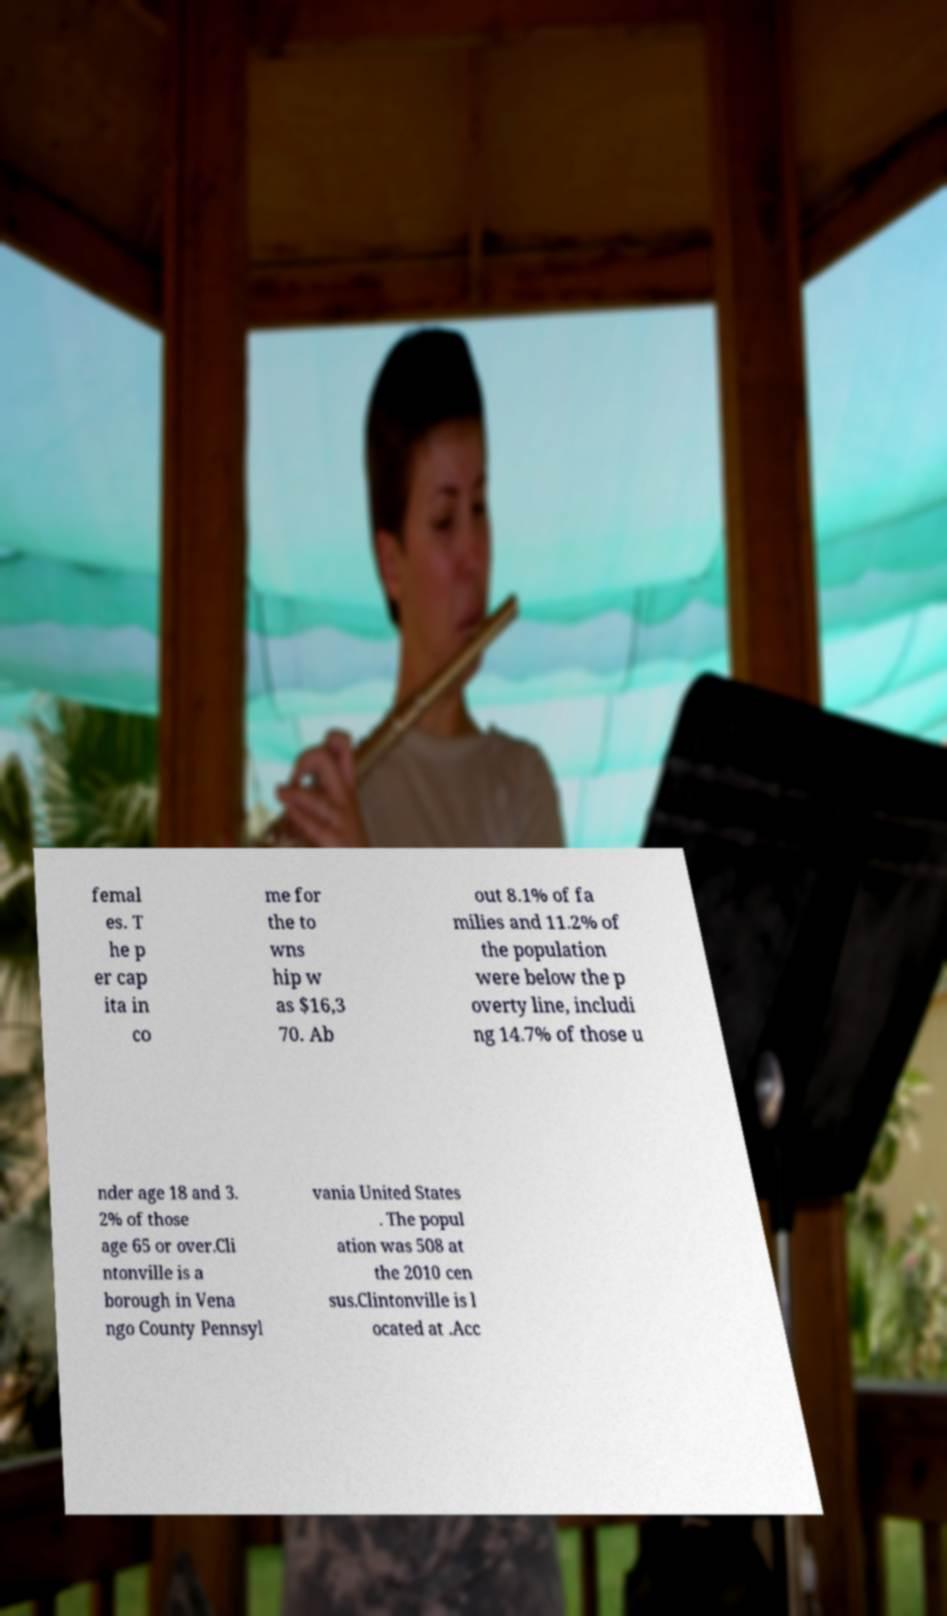There's text embedded in this image that I need extracted. Can you transcribe it verbatim? femal es. T he p er cap ita in co me for the to wns hip w as $16,3 70. Ab out 8.1% of fa milies and 11.2% of the population were below the p overty line, includi ng 14.7% of those u nder age 18 and 3. 2% of those age 65 or over.Cli ntonville is a borough in Vena ngo County Pennsyl vania United States . The popul ation was 508 at the 2010 cen sus.Clintonville is l ocated at .Acc 